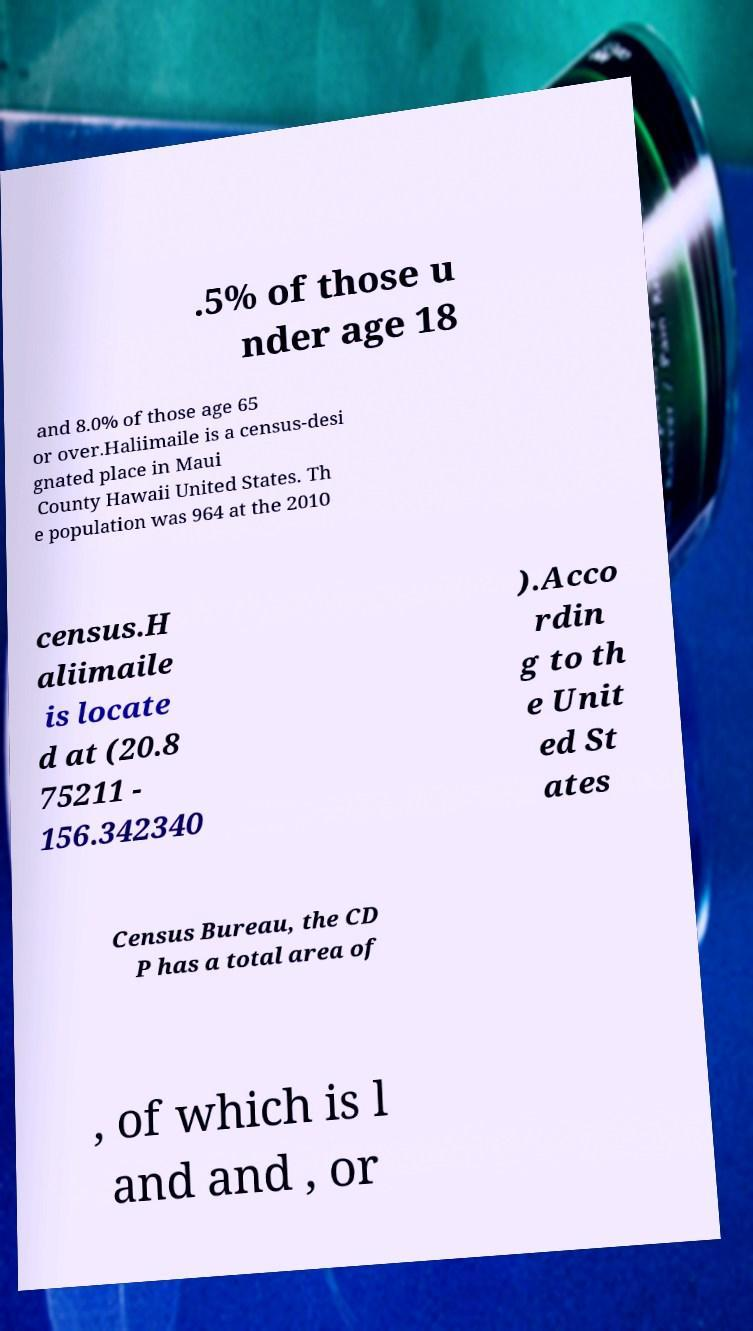Please read and relay the text visible in this image. What does it say? .5% of those u nder age 18 and 8.0% of those age 65 or over.Haliimaile is a census-desi gnated place in Maui County Hawaii United States. Th e population was 964 at the 2010 census.H aliimaile is locate d at (20.8 75211 - 156.342340 ).Acco rdin g to th e Unit ed St ates Census Bureau, the CD P has a total area of , of which is l and and , or 